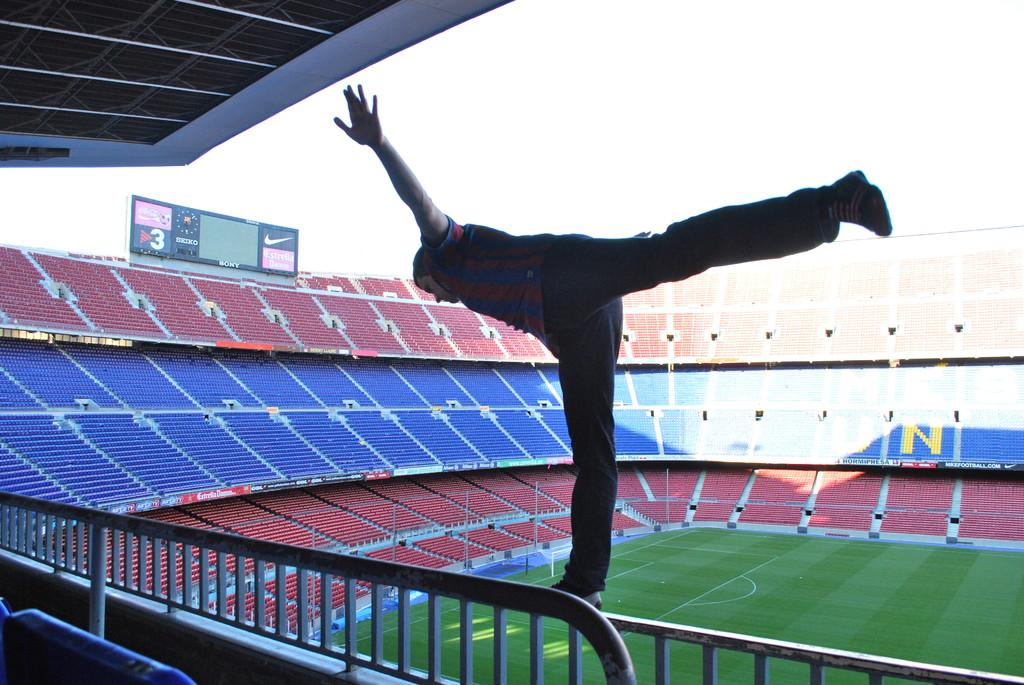What type of structure is the main subject of the image? There is a stadium in the image. What can be seen on the field or inside the stadium? There is a display screen visible in the image. Can you describe the person's position in the image? There is a person standing on the grill in the image. What other structure is present in the image? There is a shed in the image. What is visible in the background of the image? The sky is visible in the image. What type of cord is being used to tie the grape to the sheet in the image? There is no cord, grape, or sheet present in the image. 